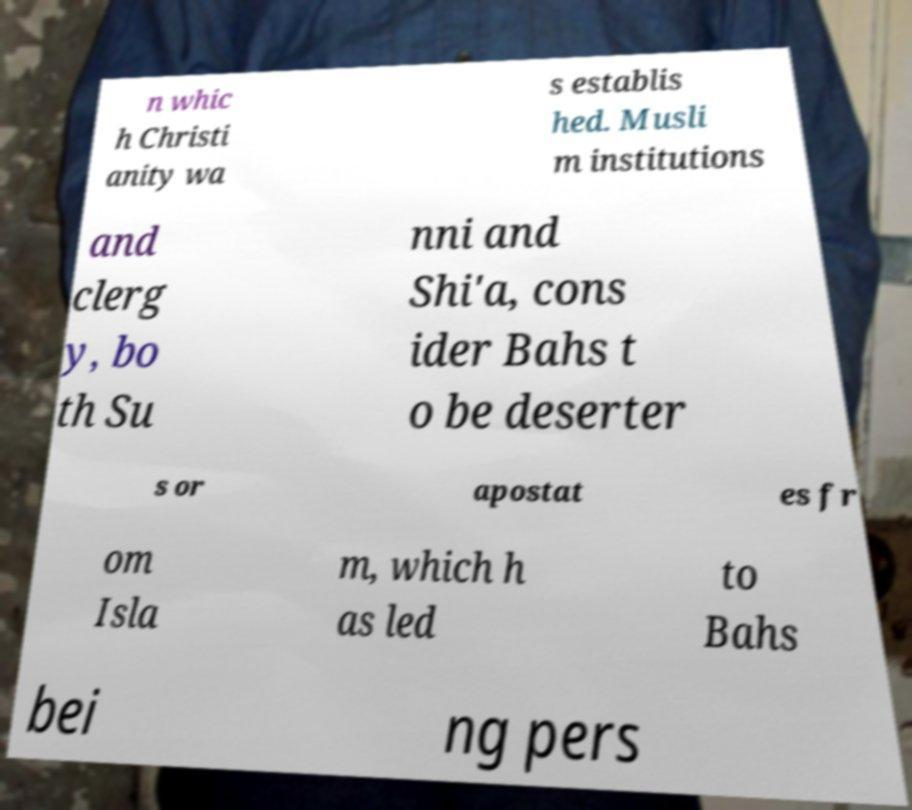For documentation purposes, I need the text within this image transcribed. Could you provide that? n whic h Christi anity wa s establis hed. Musli m institutions and clerg y, bo th Su nni and Shi'a, cons ider Bahs t o be deserter s or apostat es fr om Isla m, which h as led to Bahs bei ng pers 